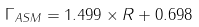<formula> <loc_0><loc_0><loc_500><loc_500>\Gamma _ { A S M } = 1 . 4 9 9 \times R + 0 . 6 9 8</formula> 